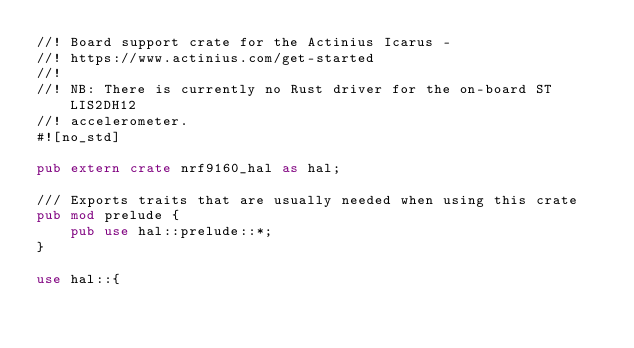<code> <loc_0><loc_0><loc_500><loc_500><_Rust_>//! Board support crate for the Actinius Icarus -
//! https://www.actinius.com/get-started
//!
//! NB: There is currently no Rust driver for the on-board ST LIS2DH12
//! accelerometer.
#![no_std]

pub extern crate nrf9160_hal as hal;

/// Exports traits that are usually needed when using this crate
pub mod prelude {
    pub use hal::prelude::*;
}

use hal::{</code> 